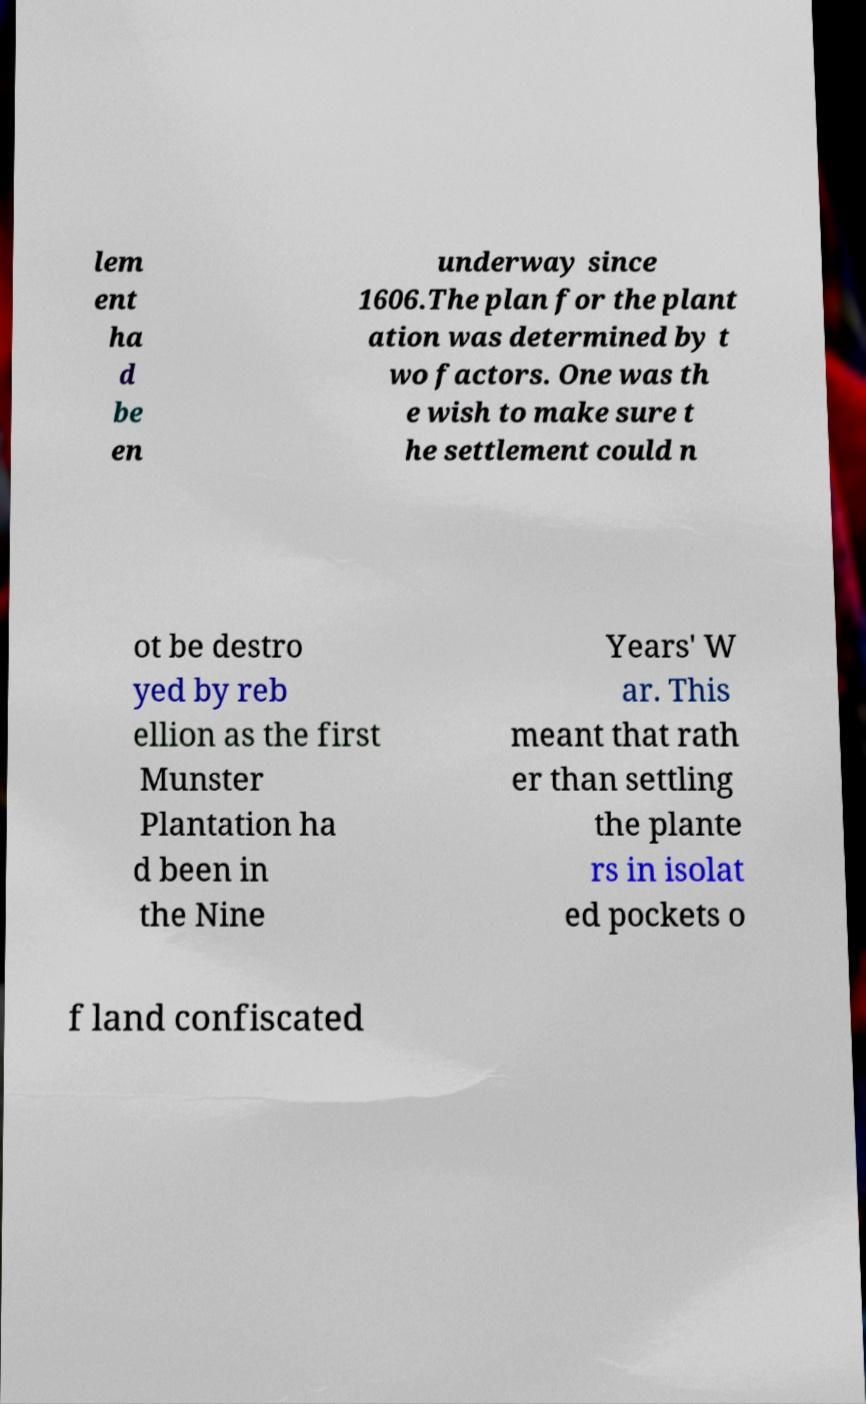Please identify and transcribe the text found in this image. lem ent ha d be en underway since 1606.The plan for the plant ation was determined by t wo factors. One was th e wish to make sure t he settlement could n ot be destro yed by reb ellion as the first Munster Plantation ha d been in the Nine Years' W ar. This meant that rath er than settling the plante rs in isolat ed pockets o f land confiscated 